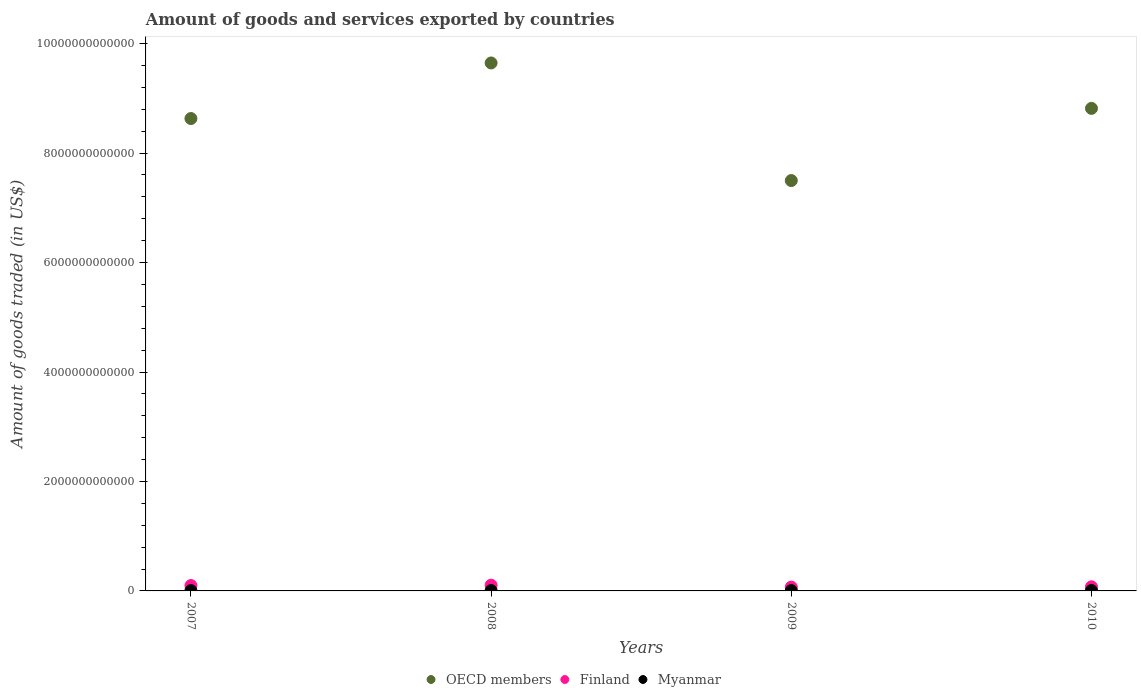How many different coloured dotlines are there?
Your answer should be very brief. 3. What is the total amount of goods and services exported in Finland in 2010?
Make the answer very short. 7.51e+1. Across all years, what is the maximum total amount of goods and services exported in OECD members?
Give a very brief answer. 9.65e+12. Across all years, what is the minimum total amount of goods and services exported in OECD members?
Your response must be concise. 7.50e+12. In which year was the total amount of goods and services exported in OECD members minimum?
Offer a very short reply. 2009. What is the total total amount of goods and services exported in Finland in the graph?
Provide a succinct answer. 3.48e+11. What is the difference between the total amount of goods and services exported in OECD members in 2007 and that in 2008?
Offer a terse response. -1.02e+12. What is the difference between the total amount of goods and services exported in Finland in 2010 and the total amount of goods and services exported in OECD members in 2009?
Your answer should be very brief. -7.42e+12. What is the average total amount of goods and services exported in Finland per year?
Offer a terse response. 8.70e+1. In the year 2009, what is the difference between the total amount of goods and services exported in Myanmar and total amount of goods and services exported in OECD members?
Your answer should be compact. -7.49e+12. In how many years, is the total amount of goods and services exported in Finland greater than 6000000000000 US$?
Give a very brief answer. 0. What is the ratio of the total amount of goods and services exported in OECD members in 2008 to that in 2010?
Provide a succinct answer. 1.09. Is the total amount of goods and services exported in Myanmar in 2007 less than that in 2009?
Ensure brevity in your answer.  Yes. Is the difference between the total amount of goods and services exported in Myanmar in 2009 and 2010 greater than the difference between the total amount of goods and services exported in OECD members in 2009 and 2010?
Your answer should be very brief. Yes. What is the difference between the highest and the second highest total amount of goods and services exported in OECD members?
Your answer should be compact. 8.30e+11. What is the difference between the highest and the lowest total amount of goods and services exported in OECD members?
Ensure brevity in your answer.  2.15e+12. Is it the case that in every year, the sum of the total amount of goods and services exported in OECD members and total amount of goods and services exported in Finland  is greater than the total amount of goods and services exported in Myanmar?
Provide a succinct answer. Yes. Does the total amount of goods and services exported in OECD members monotonically increase over the years?
Ensure brevity in your answer.  No. What is the difference between two consecutive major ticks on the Y-axis?
Make the answer very short. 2.00e+12. Does the graph contain any zero values?
Provide a short and direct response. No. How many legend labels are there?
Ensure brevity in your answer.  3. How are the legend labels stacked?
Offer a terse response. Horizontal. What is the title of the graph?
Make the answer very short. Amount of goods and services exported by countries. Does "Arab World" appear as one of the legend labels in the graph?
Keep it short and to the point. No. What is the label or title of the Y-axis?
Give a very brief answer. Amount of goods traded (in US$). What is the Amount of goods traded (in US$) in OECD members in 2007?
Provide a short and direct response. 8.63e+12. What is the Amount of goods traded (in US$) in Finland in 2007?
Make the answer very short. 9.82e+1. What is the Amount of goods traded (in US$) of Myanmar in 2007?
Provide a succinct answer. 5.40e+09. What is the Amount of goods traded (in US$) of OECD members in 2008?
Your response must be concise. 9.65e+12. What is the Amount of goods traded (in US$) in Finland in 2008?
Offer a terse response. 1.05e+11. What is the Amount of goods traded (in US$) of Myanmar in 2008?
Offer a very short reply. 5.91e+09. What is the Amount of goods traded (in US$) of OECD members in 2009?
Ensure brevity in your answer.  7.50e+12. What is the Amount of goods traded (in US$) in Finland in 2009?
Keep it short and to the point. 6.99e+1. What is the Amount of goods traded (in US$) of Myanmar in 2009?
Your response must be concise. 5.90e+09. What is the Amount of goods traded (in US$) in OECD members in 2010?
Provide a short and direct response. 8.82e+12. What is the Amount of goods traded (in US$) of Finland in 2010?
Offer a terse response. 7.51e+1. What is the Amount of goods traded (in US$) in Myanmar in 2010?
Keep it short and to the point. 7.33e+09. Across all years, what is the maximum Amount of goods traded (in US$) in OECD members?
Make the answer very short. 9.65e+12. Across all years, what is the maximum Amount of goods traded (in US$) in Finland?
Your response must be concise. 1.05e+11. Across all years, what is the maximum Amount of goods traded (in US$) of Myanmar?
Your response must be concise. 7.33e+09. Across all years, what is the minimum Amount of goods traded (in US$) in OECD members?
Provide a succinct answer. 7.50e+12. Across all years, what is the minimum Amount of goods traded (in US$) in Finland?
Provide a short and direct response. 6.99e+1. Across all years, what is the minimum Amount of goods traded (in US$) in Myanmar?
Ensure brevity in your answer.  5.40e+09. What is the total Amount of goods traded (in US$) of OECD members in the graph?
Provide a succinct answer. 3.46e+13. What is the total Amount of goods traded (in US$) in Finland in the graph?
Offer a terse response. 3.48e+11. What is the total Amount of goods traded (in US$) of Myanmar in the graph?
Give a very brief answer. 2.45e+1. What is the difference between the Amount of goods traded (in US$) of OECD members in 2007 and that in 2008?
Provide a succinct answer. -1.02e+12. What is the difference between the Amount of goods traded (in US$) of Finland in 2007 and that in 2008?
Provide a succinct answer. -6.61e+09. What is the difference between the Amount of goods traded (in US$) of Myanmar in 2007 and that in 2008?
Offer a very short reply. -5.03e+08. What is the difference between the Amount of goods traded (in US$) in OECD members in 2007 and that in 2009?
Keep it short and to the point. 1.13e+12. What is the difference between the Amount of goods traded (in US$) of Finland in 2007 and that in 2009?
Provide a short and direct response. 2.83e+1. What is the difference between the Amount of goods traded (in US$) of Myanmar in 2007 and that in 2009?
Provide a succinct answer. -5.01e+08. What is the difference between the Amount of goods traded (in US$) in OECD members in 2007 and that in 2010?
Give a very brief answer. -1.86e+11. What is the difference between the Amount of goods traded (in US$) of Finland in 2007 and that in 2010?
Offer a very short reply. 2.31e+1. What is the difference between the Amount of goods traded (in US$) in Myanmar in 2007 and that in 2010?
Your response must be concise. -1.93e+09. What is the difference between the Amount of goods traded (in US$) of OECD members in 2008 and that in 2009?
Make the answer very short. 2.15e+12. What is the difference between the Amount of goods traded (in US$) of Finland in 2008 and that in 2009?
Ensure brevity in your answer.  3.49e+1. What is the difference between the Amount of goods traded (in US$) in Myanmar in 2008 and that in 2009?
Your response must be concise. 1.92e+06. What is the difference between the Amount of goods traded (in US$) in OECD members in 2008 and that in 2010?
Provide a succinct answer. 8.30e+11. What is the difference between the Amount of goods traded (in US$) of Finland in 2008 and that in 2010?
Your answer should be compact. 2.97e+1. What is the difference between the Amount of goods traded (in US$) of Myanmar in 2008 and that in 2010?
Ensure brevity in your answer.  -1.43e+09. What is the difference between the Amount of goods traded (in US$) in OECD members in 2009 and that in 2010?
Your response must be concise. -1.32e+12. What is the difference between the Amount of goods traded (in US$) in Finland in 2009 and that in 2010?
Offer a very short reply. -5.12e+09. What is the difference between the Amount of goods traded (in US$) in Myanmar in 2009 and that in 2010?
Keep it short and to the point. -1.43e+09. What is the difference between the Amount of goods traded (in US$) of OECD members in 2007 and the Amount of goods traded (in US$) of Finland in 2008?
Give a very brief answer. 8.53e+12. What is the difference between the Amount of goods traded (in US$) in OECD members in 2007 and the Amount of goods traded (in US$) in Myanmar in 2008?
Give a very brief answer. 8.63e+12. What is the difference between the Amount of goods traded (in US$) in Finland in 2007 and the Amount of goods traded (in US$) in Myanmar in 2008?
Offer a terse response. 9.23e+1. What is the difference between the Amount of goods traded (in US$) of OECD members in 2007 and the Amount of goods traded (in US$) of Finland in 2009?
Offer a terse response. 8.56e+12. What is the difference between the Amount of goods traded (in US$) of OECD members in 2007 and the Amount of goods traded (in US$) of Myanmar in 2009?
Keep it short and to the point. 8.63e+12. What is the difference between the Amount of goods traded (in US$) of Finland in 2007 and the Amount of goods traded (in US$) of Myanmar in 2009?
Keep it short and to the point. 9.23e+1. What is the difference between the Amount of goods traded (in US$) in OECD members in 2007 and the Amount of goods traded (in US$) in Finland in 2010?
Give a very brief answer. 8.56e+12. What is the difference between the Amount of goods traded (in US$) of OECD members in 2007 and the Amount of goods traded (in US$) of Myanmar in 2010?
Provide a succinct answer. 8.62e+12. What is the difference between the Amount of goods traded (in US$) of Finland in 2007 and the Amount of goods traded (in US$) of Myanmar in 2010?
Give a very brief answer. 9.09e+1. What is the difference between the Amount of goods traded (in US$) in OECD members in 2008 and the Amount of goods traded (in US$) in Finland in 2009?
Keep it short and to the point. 9.58e+12. What is the difference between the Amount of goods traded (in US$) of OECD members in 2008 and the Amount of goods traded (in US$) of Myanmar in 2009?
Provide a succinct answer. 9.64e+12. What is the difference between the Amount of goods traded (in US$) in Finland in 2008 and the Amount of goods traded (in US$) in Myanmar in 2009?
Ensure brevity in your answer.  9.89e+1. What is the difference between the Amount of goods traded (in US$) in OECD members in 2008 and the Amount of goods traded (in US$) in Finland in 2010?
Your answer should be compact. 9.57e+12. What is the difference between the Amount of goods traded (in US$) in OECD members in 2008 and the Amount of goods traded (in US$) in Myanmar in 2010?
Keep it short and to the point. 9.64e+12. What is the difference between the Amount of goods traded (in US$) of Finland in 2008 and the Amount of goods traded (in US$) of Myanmar in 2010?
Ensure brevity in your answer.  9.75e+1. What is the difference between the Amount of goods traded (in US$) of OECD members in 2009 and the Amount of goods traded (in US$) of Finland in 2010?
Provide a succinct answer. 7.42e+12. What is the difference between the Amount of goods traded (in US$) in OECD members in 2009 and the Amount of goods traded (in US$) in Myanmar in 2010?
Offer a terse response. 7.49e+12. What is the difference between the Amount of goods traded (in US$) in Finland in 2009 and the Amount of goods traded (in US$) in Myanmar in 2010?
Your answer should be very brief. 6.26e+1. What is the average Amount of goods traded (in US$) in OECD members per year?
Your answer should be compact. 8.65e+12. What is the average Amount of goods traded (in US$) of Finland per year?
Provide a short and direct response. 8.70e+1. What is the average Amount of goods traded (in US$) in Myanmar per year?
Ensure brevity in your answer.  6.14e+09. In the year 2007, what is the difference between the Amount of goods traded (in US$) of OECD members and Amount of goods traded (in US$) of Finland?
Offer a terse response. 8.53e+12. In the year 2007, what is the difference between the Amount of goods traded (in US$) of OECD members and Amount of goods traded (in US$) of Myanmar?
Offer a terse response. 8.63e+12. In the year 2007, what is the difference between the Amount of goods traded (in US$) of Finland and Amount of goods traded (in US$) of Myanmar?
Provide a short and direct response. 9.28e+1. In the year 2008, what is the difference between the Amount of goods traded (in US$) of OECD members and Amount of goods traded (in US$) of Finland?
Your answer should be compact. 9.54e+12. In the year 2008, what is the difference between the Amount of goods traded (in US$) in OECD members and Amount of goods traded (in US$) in Myanmar?
Offer a very short reply. 9.64e+12. In the year 2008, what is the difference between the Amount of goods traded (in US$) in Finland and Amount of goods traded (in US$) in Myanmar?
Your response must be concise. 9.89e+1. In the year 2009, what is the difference between the Amount of goods traded (in US$) in OECD members and Amount of goods traded (in US$) in Finland?
Offer a very short reply. 7.43e+12. In the year 2009, what is the difference between the Amount of goods traded (in US$) in OECD members and Amount of goods traded (in US$) in Myanmar?
Make the answer very short. 7.49e+12. In the year 2009, what is the difference between the Amount of goods traded (in US$) in Finland and Amount of goods traded (in US$) in Myanmar?
Your response must be concise. 6.40e+1. In the year 2010, what is the difference between the Amount of goods traded (in US$) of OECD members and Amount of goods traded (in US$) of Finland?
Your answer should be very brief. 8.74e+12. In the year 2010, what is the difference between the Amount of goods traded (in US$) in OECD members and Amount of goods traded (in US$) in Myanmar?
Give a very brief answer. 8.81e+12. In the year 2010, what is the difference between the Amount of goods traded (in US$) in Finland and Amount of goods traded (in US$) in Myanmar?
Offer a terse response. 6.77e+1. What is the ratio of the Amount of goods traded (in US$) of OECD members in 2007 to that in 2008?
Your response must be concise. 0.89. What is the ratio of the Amount of goods traded (in US$) of Finland in 2007 to that in 2008?
Your response must be concise. 0.94. What is the ratio of the Amount of goods traded (in US$) of Myanmar in 2007 to that in 2008?
Provide a short and direct response. 0.91. What is the ratio of the Amount of goods traded (in US$) of OECD members in 2007 to that in 2009?
Ensure brevity in your answer.  1.15. What is the ratio of the Amount of goods traded (in US$) of Finland in 2007 to that in 2009?
Offer a very short reply. 1.4. What is the ratio of the Amount of goods traded (in US$) of Myanmar in 2007 to that in 2009?
Make the answer very short. 0.92. What is the ratio of the Amount of goods traded (in US$) in OECD members in 2007 to that in 2010?
Make the answer very short. 0.98. What is the ratio of the Amount of goods traded (in US$) of Finland in 2007 to that in 2010?
Make the answer very short. 1.31. What is the ratio of the Amount of goods traded (in US$) of Myanmar in 2007 to that in 2010?
Your answer should be very brief. 0.74. What is the ratio of the Amount of goods traded (in US$) of OECD members in 2008 to that in 2009?
Ensure brevity in your answer.  1.29. What is the ratio of the Amount of goods traded (in US$) in Finland in 2008 to that in 2009?
Provide a short and direct response. 1.5. What is the ratio of the Amount of goods traded (in US$) in Myanmar in 2008 to that in 2009?
Make the answer very short. 1. What is the ratio of the Amount of goods traded (in US$) in OECD members in 2008 to that in 2010?
Offer a very short reply. 1.09. What is the ratio of the Amount of goods traded (in US$) of Finland in 2008 to that in 2010?
Keep it short and to the point. 1.4. What is the ratio of the Amount of goods traded (in US$) of Myanmar in 2008 to that in 2010?
Your answer should be compact. 0.81. What is the ratio of the Amount of goods traded (in US$) in OECD members in 2009 to that in 2010?
Provide a short and direct response. 0.85. What is the ratio of the Amount of goods traded (in US$) in Finland in 2009 to that in 2010?
Keep it short and to the point. 0.93. What is the ratio of the Amount of goods traded (in US$) of Myanmar in 2009 to that in 2010?
Provide a short and direct response. 0.8. What is the difference between the highest and the second highest Amount of goods traded (in US$) of OECD members?
Your answer should be compact. 8.30e+11. What is the difference between the highest and the second highest Amount of goods traded (in US$) in Finland?
Ensure brevity in your answer.  6.61e+09. What is the difference between the highest and the second highest Amount of goods traded (in US$) in Myanmar?
Give a very brief answer. 1.43e+09. What is the difference between the highest and the lowest Amount of goods traded (in US$) of OECD members?
Ensure brevity in your answer.  2.15e+12. What is the difference between the highest and the lowest Amount of goods traded (in US$) of Finland?
Offer a terse response. 3.49e+1. What is the difference between the highest and the lowest Amount of goods traded (in US$) of Myanmar?
Provide a succinct answer. 1.93e+09. 